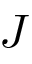<formula> <loc_0><loc_0><loc_500><loc_500>J</formula> 